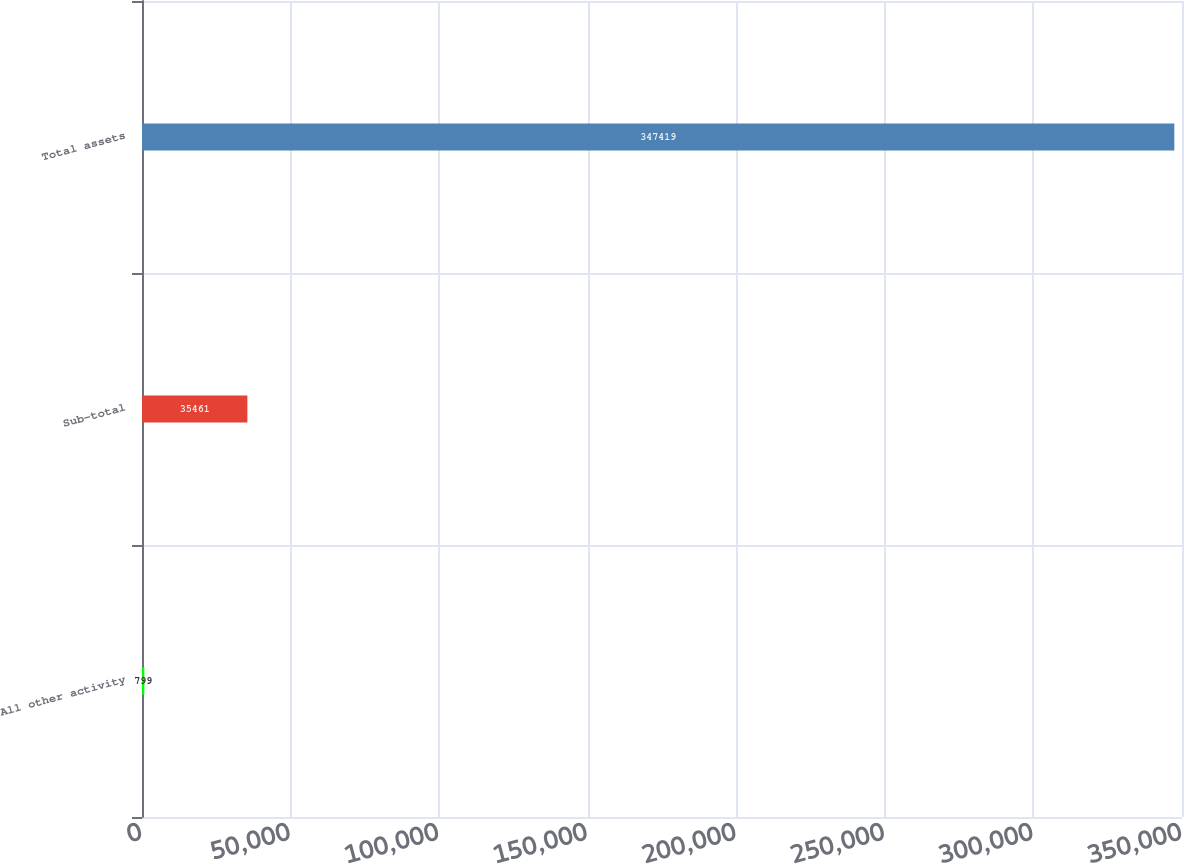Convert chart to OTSL. <chart><loc_0><loc_0><loc_500><loc_500><bar_chart><fcel>All other activity<fcel>Sub-total<fcel>Total assets<nl><fcel>799<fcel>35461<fcel>347419<nl></chart> 